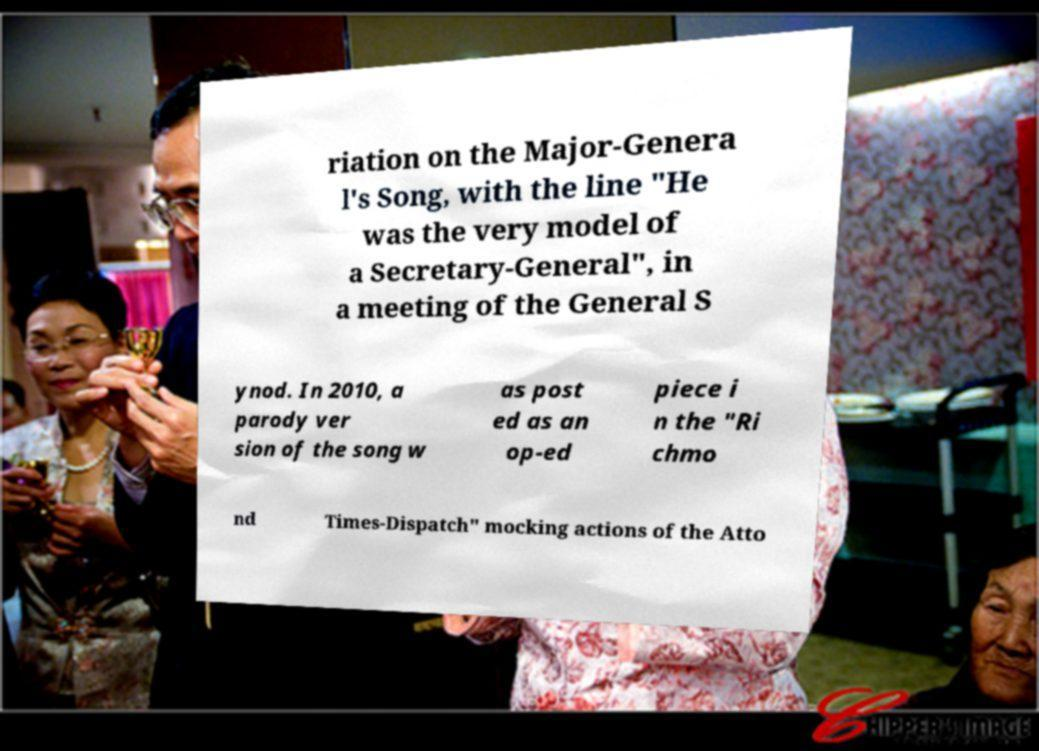Please read and relay the text visible in this image. What does it say? riation on the Major-Genera l's Song, with the line "He was the very model of a Secretary-General", in a meeting of the General S ynod. In 2010, a parody ver sion of the song w as post ed as an op-ed piece i n the "Ri chmo nd Times-Dispatch" mocking actions of the Atto 